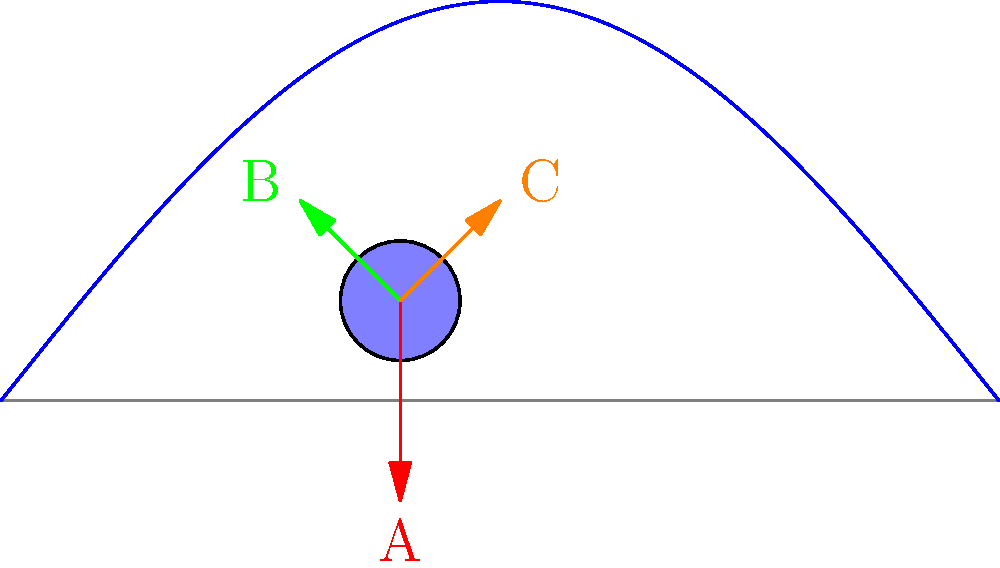In the context of a runner's gait cycle, which force vector represents the ground reaction force during the mid-stance phase? To answer this question, let's analyze the force vectors acting on the runner's foot during different phases of the gait cycle:

1. Vector A (red): This vertical vector pointing downwards represents the body weight and the impact force during initial contact or heel strike. It's not the primary force during mid-stance.

2. Vector B (green): This vector pointing forward and upward represents the propulsive force during the push-off phase, which occurs after mid-stance.

3. Vector C (orange): This vector pointing upward and slightly backward represents the ground reaction force during the mid-stance phase.

The mid-stance phase occurs when the foot is fully in contact with the ground, and the body's center of mass is directly over the foot. During this phase, the ground reaction force is primarily vertical to counteract the body weight and provide support.

Vector C best represents this force because:
1. It's primarily vertical, counteracting gravity.
2. It has a slight backward component, which helps in slowing down the forward momentum of the body, preparing for the propulsive phase.

Therefore, Vector C (orange) represents the ground reaction force during the mid-stance phase of the runner's gait cycle.
Answer: Vector C (orange) 